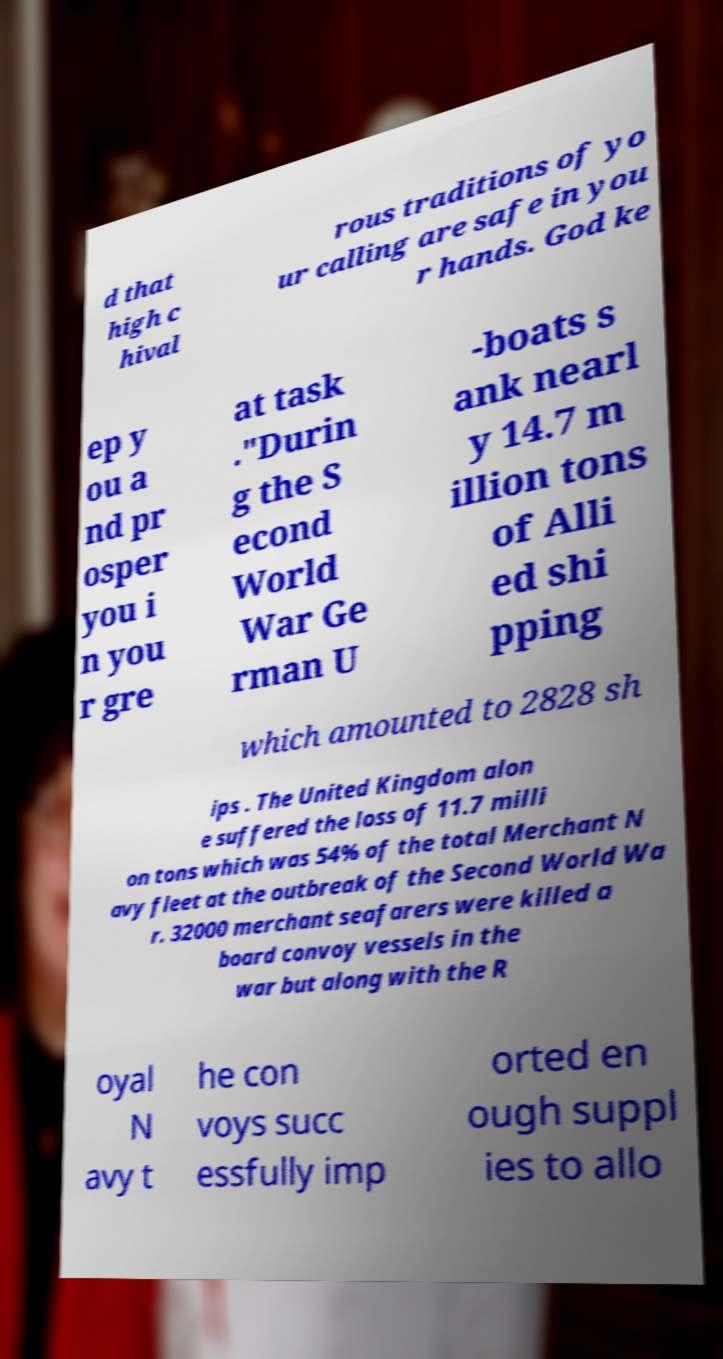Can you accurately transcribe the text from the provided image for me? d that high c hival rous traditions of yo ur calling are safe in you r hands. God ke ep y ou a nd pr osper you i n you r gre at task ."Durin g the S econd World War Ge rman U -boats s ank nearl y 14.7 m illion tons of Alli ed shi pping which amounted to 2828 sh ips . The United Kingdom alon e suffered the loss of 11.7 milli on tons which was 54% of the total Merchant N avy fleet at the outbreak of the Second World Wa r. 32000 merchant seafarers were killed a board convoy vessels in the war but along with the R oyal N avy t he con voys succ essfully imp orted en ough suppl ies to allo 